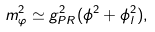<formula> <loc_0><loc_0><loc_500><loc_500>m _ { \varphi } ^ { 2 } \simeq g _ { P R } ^ { 2 } ( \phi ^ { 2 } + \phi _ { l } ^ { 2 } ) ,</formula> 